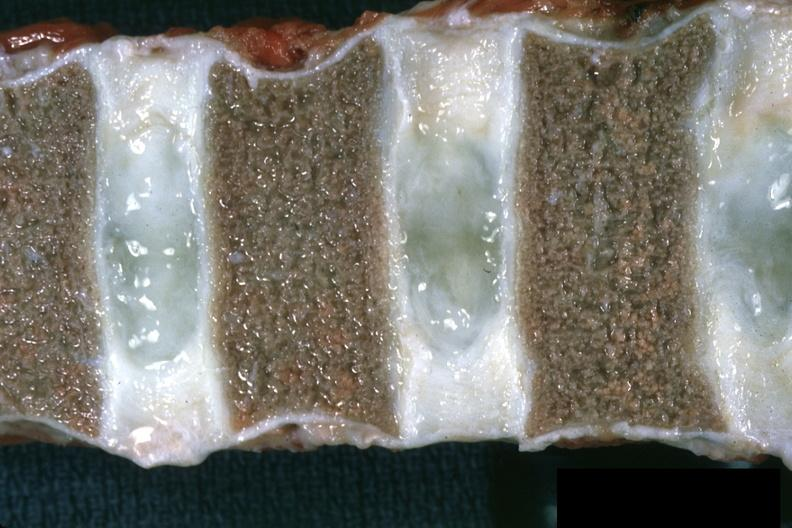what are close-up view well shown normal discs case of chronic myelogenous leukemia in a 14yo male vertebra collapsed?
Answer the question using a single word or phrase. Vertebra somewhat 